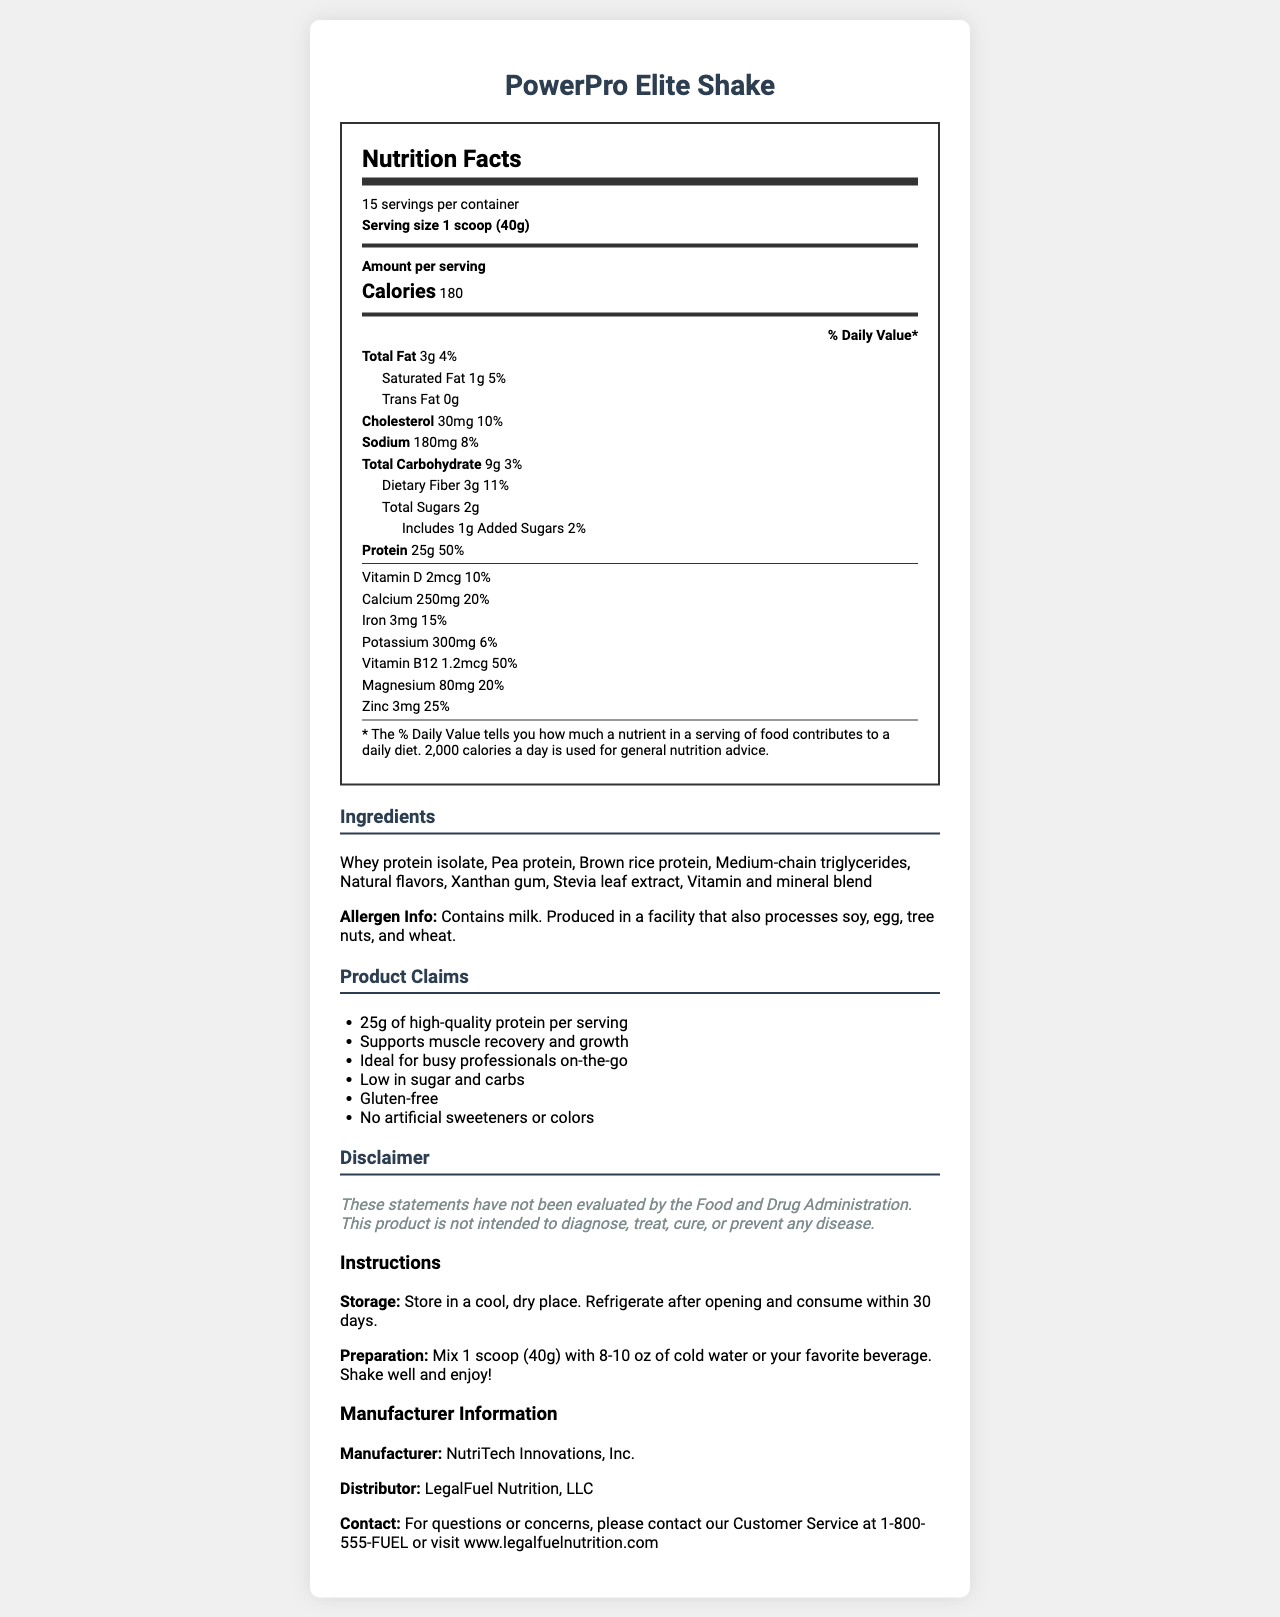what is the serving size of PowerPro Elite Shake? The document lists the serving size as "1 scoop (40g)".
Answer: 1 scoop (40g) how many calories are there per serving? The document specifies that each serving contains 180 calories.
Answer: 180 what is the total fat content per serving? The document states that the total fat content per serving is "3g".
Answer: 3g how much dietary fiber does each serving contain? The document shows that each serving has 3g of dietary fiber.
Answer: 3g how much protein is in one serving? The document notes that each serving includes 25g of protein.
Answer: 25g how many servings are there per container? A. 10 B. 15 C. 20 D. 25 The document indicates there are 15 servings per container.
Answer: B. 15 what is the percentage of daily value for calcium? A. 10% B. 15% C. 20% D. 25% The document lists the daily value for calcium as 20%.
Answer: C. 20% does the product claim to support muscle recovery and growth? In the 'Product Claims' section, one of the claims is "Supports muscle recovery and growth".
Answer: Yes does the product contain any artificial sweeteners or colors? The document claims that the product has "No artificial sweeteners or colors" as one of its marketing claims.
Answer: No quickly summarize what the document is about. The detailed explanation is that the document provides comprehensive nutrition facts for the PowerPro Elite Shake, including caloric content, macronutrients (fat, carbohydrates, protein), vitamins, and minerals. It also lists ingredients, allergen information, marketing claims, legal disclaimers, storage, and preparation instructions. Additionally, it gives manufacturer and distributor information.
Answer: The document is about the nutrition facts, ingredients, and marketing claims for PowerPro Elite Shake, a high-protein meal replacement shake marketed to busy professionals. It includes information on serving size, calories, macronutrients, vitamins and minerals, allergens, and storage and preparation instructions. what is the amount of added sugars in a serving? The document specifies that there is 1g of added sugars per serving.
Answer: 1g how much Vitamin D does each serving provide? The document indicates that each serving contains 2mcg of Vitamin D.
Answer: 2mcg does the product contain gluten? One of the marketing claims in the document states that the product is "Gluten-free".
Answer: No how many grams of saturated fat are in one serving? The document lists that one serving contains 1g of saturated fat.
Answer: 1g what are the primary protein sources listed in the ingredients? A. Whey protein isolate, Soy protein B. Pea protein, Brown rice protein C. Whey protein isolate, Pea protein, Brown rice protein D. Whey protein isolate, Pea protein The ingredients listed in the document include "Whey protein isolate", "Pea protein", and "Brown rice protein" as the primary protein sources.
Answer: C. Whey protein isolate, Pea protein, Brown rice protein how should the product be stored after opening? The storage instructions in the document specify to "Refrigerate after opening and consume within 30 days".
Answer: Refrigerate after opening and consume within 30 days what is the contact information for customer service? The document provides the contact information as "1-800-555-FUEL or visit www.legalfuelnutrition.com".
Answer: 1-800-555-FUEL or visit www.legalfuelnutrition.com what is the amount of sodium per serving? The document states that the sodium content per serving is "180mg".
Answer: 180mg is the statement "This product is intended to diagnose, treat, cure, or prevent any disease" true for PowerPro Elite Shake? The legal disclaimer explicitly states that the product is "not intended to diagnose, treat, cure, or prevent any disease".
Answer: No how should the PowerPro Elite Shake be prepared? The preparation instructions indicate to "Mix 1 scoop (40g) with 8-10 oz of cold water or your favorite beverage. Shake well and enjoy!".
Answer: Mix 1 scoop (40g) with 8-10 oz of cold water or your favorite beverage. Shake well and enjoy! what facility might also process the PowerPro Elite Shake? The allergen information section indicates that the product is made in a facility processing soy, egg, tree nuts, and wheat.
Answer: The product is produced in a facility that also processes soy, egg, tree nuts, and wheat. where is the product manufactured? The document states that the manufacturer is "NutriTech Innovations, Inc."
Answer: NutriTech Innovations, Inc. what is the source of the document's HTML content? The document provides no information about the source of its HTML content or the code generation process.
Answer: Cannot be determined 